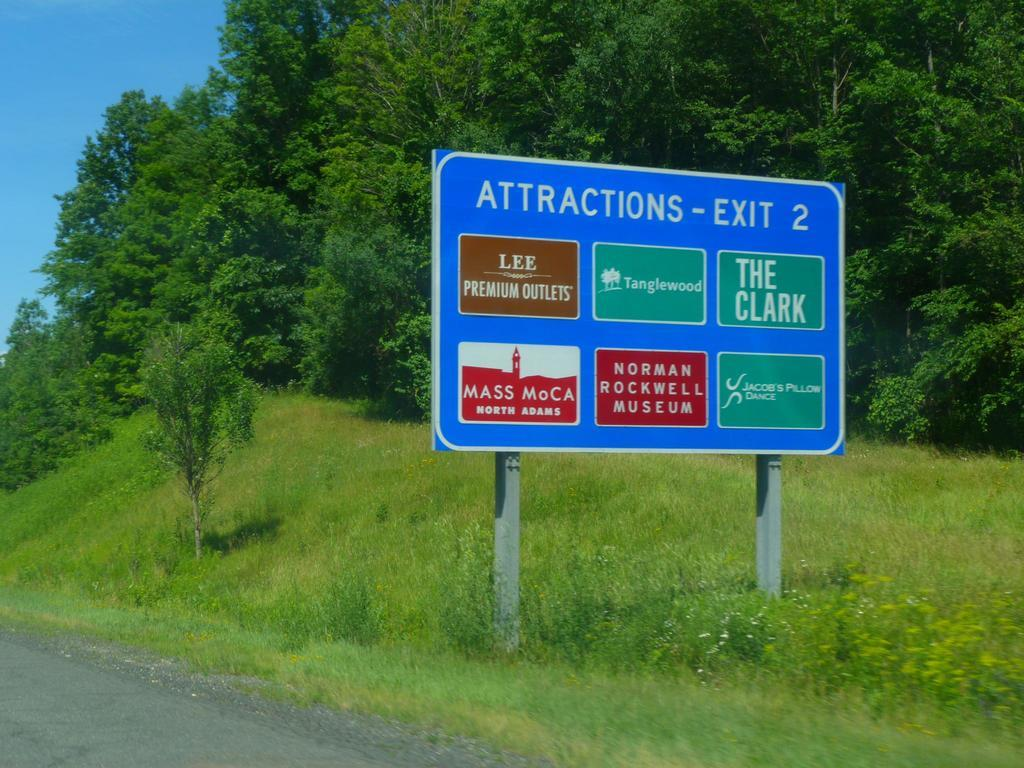<image>
Create a compact narrative representing the image presented. A highway sign lists the attractions located off exit 2. 